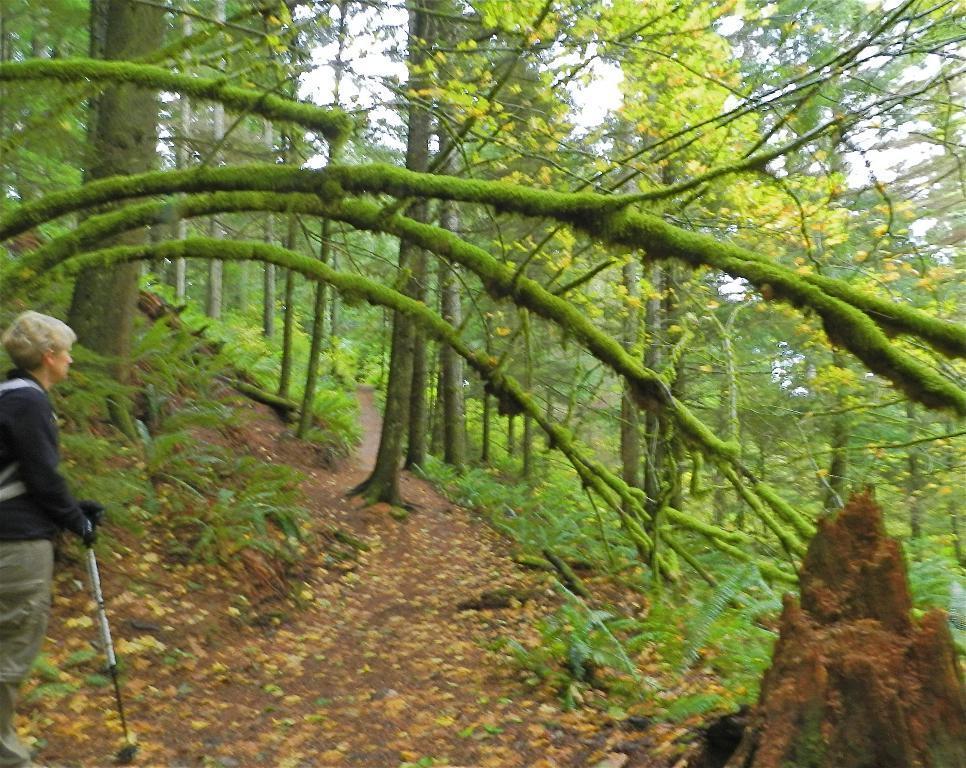Describe this image in one or two sentences. On the left side of the image there is a person holding the stick. At the bottom of the image there are flowers on the surface. There are plants, trees. At the top of the image there is sky. 